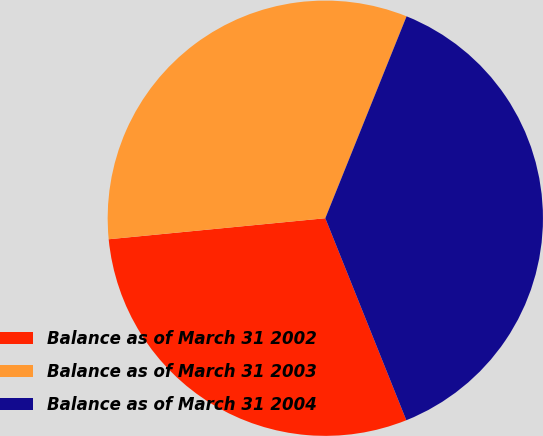Convert chart. <chart><loc_0><loc_0><loc_500><loc_500><pie_chart><fcel>Balance as of March 31 2002<fcel>Balance as of March 31 2003<fcel>Balance as of March 31 2004<nl><fcel>29.53%<fcel>32.63%<fcel>37.84%<nl></chart> 